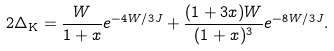<formula> <loc_0><loc_0><loc_500><loc_500>2 \Delta _ { \text {K} } = \frac { W } { 1 + x } e ^ { - 4 W / 3 J } + \frac { ( 1 + 3 x ) W } { ( 1 + x ) ^ { 3 } } e ^ { - 8 W / 3 J } .</formula> 